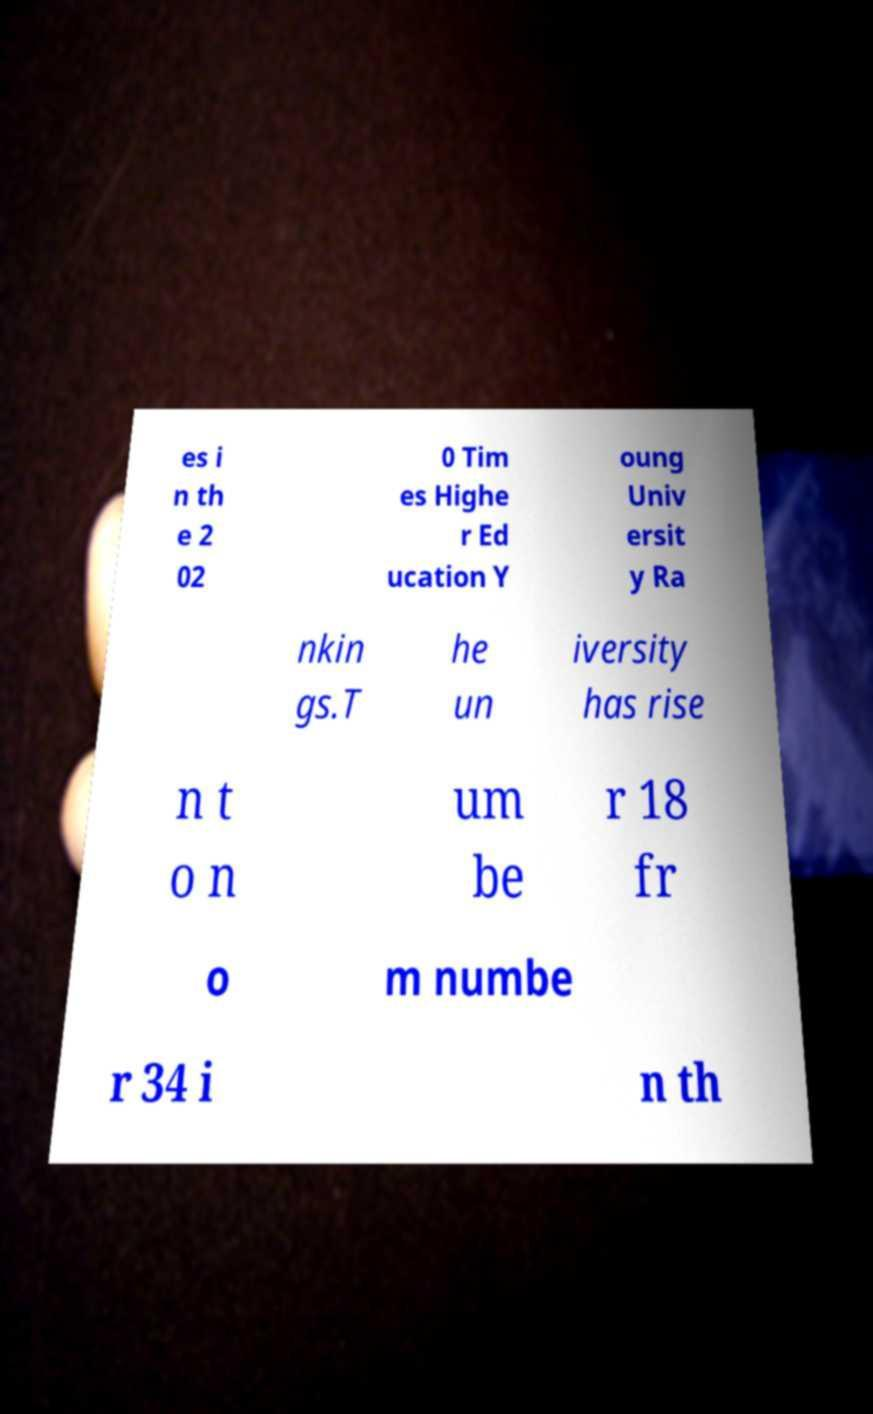Could you assist in decoding the text presented in this image and type it out clearly? es i n th e 2 02 0 Tim es Highe r Ed ucation Y oung Univ ersit y Ra nkin gs.T he un iversity has rise n t o n um be r 18 fr o m numbe r 34 i n th 